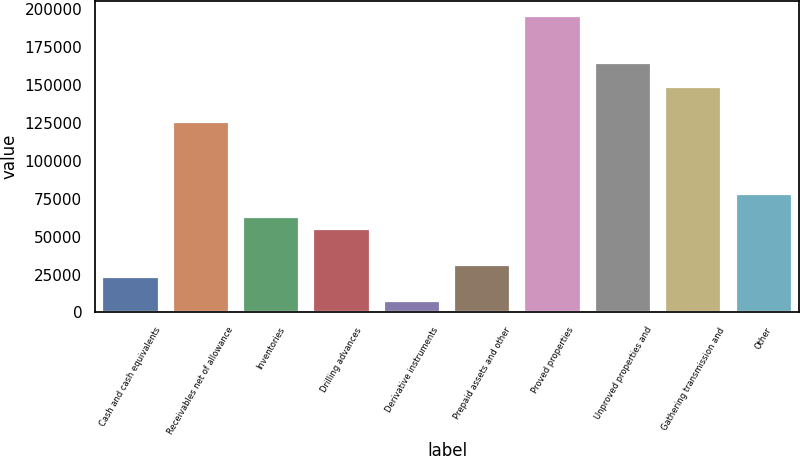<chart> <loc_0><loc_0><loc_500><loc_500><bar_chart><fcel>Cash and cash equivalents<fcel>Receivables net of allowance<fcel>Inventories<fcel>Drilling advances<fcel>Derivative instruments<fcel>Prepaid assets and other<fcel>Proved properties<fcel>Unproved properties and<fcel>Gathering transmission and<fcel>Other<nl><fcel>23535.9<fcel>125395<fcel>62712.4<fcel>54877.1<fcel>7865.3<fcel>31371.2<fcel>195912<fcel>164571<fcel>148901<fcel>78383<nl></chart> 